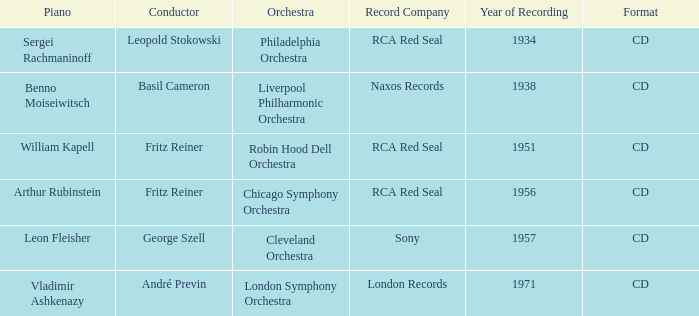Which orchestra possesses a recording made in 1951? Robin Hood Dell Orchestra. 